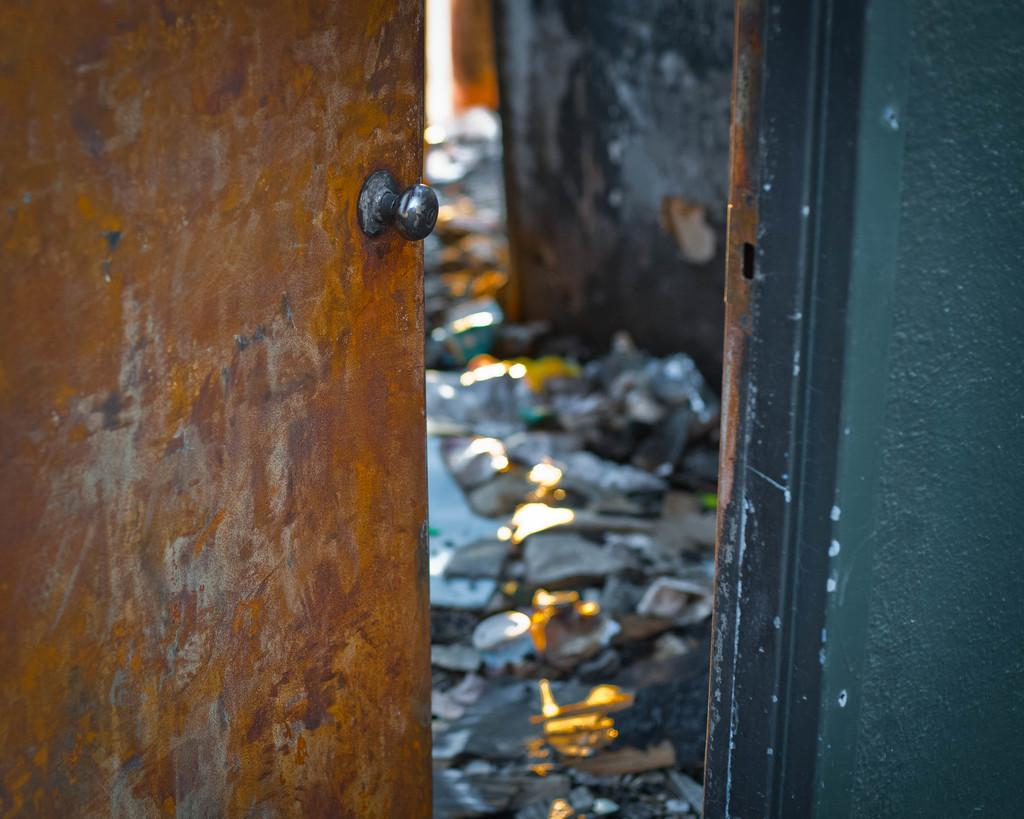What type of structure can be seen in the image? There is a door and a wall in the image. Can you describe the condition of the floor in the image? There is waste on the floor in the image. Are there any fairies visible in the image? No, there are no fairies present in the image. What type of knee injury can be seen in the image? There is no knee injury visible in the image. 